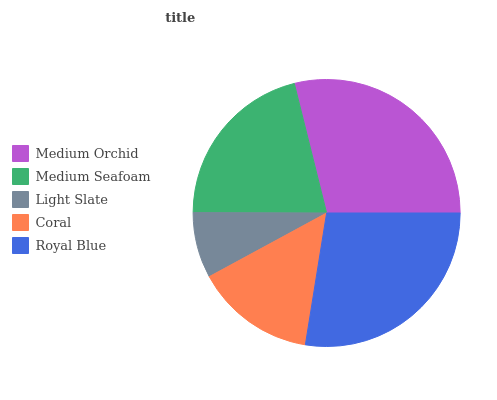Is Light Slate the minimum?
Answer yes or no. Yes. Is Medium Orchid the maximum?
Answer yes or no. Yes. Is Medium Seafoam the minimum?
Answer yes or no. No. Is Medium Seafoam the maximum?
Answer yes or no. No. Is Medium Orchid greater than Medium Seafoam?
Answer yes or no. Yes. Is Medium Seafoam less than Medium Orchid?
Answer yes or no. Yes. Is Medium Seafoam greater than Medium Orchid?
Answer yes or no. No. Is Medium Orchid less than Medium Seafoam?
Answer yes or no. No. Is Medium Seafoam the high median?
Answer yes or no. Yes. Is Medium Seafoam the low median?
Answer yes or no. Yes. Is Royal Blue the high median?
Answer yes or no. No. Is Coral the low median?
Answer yes or no. No. 